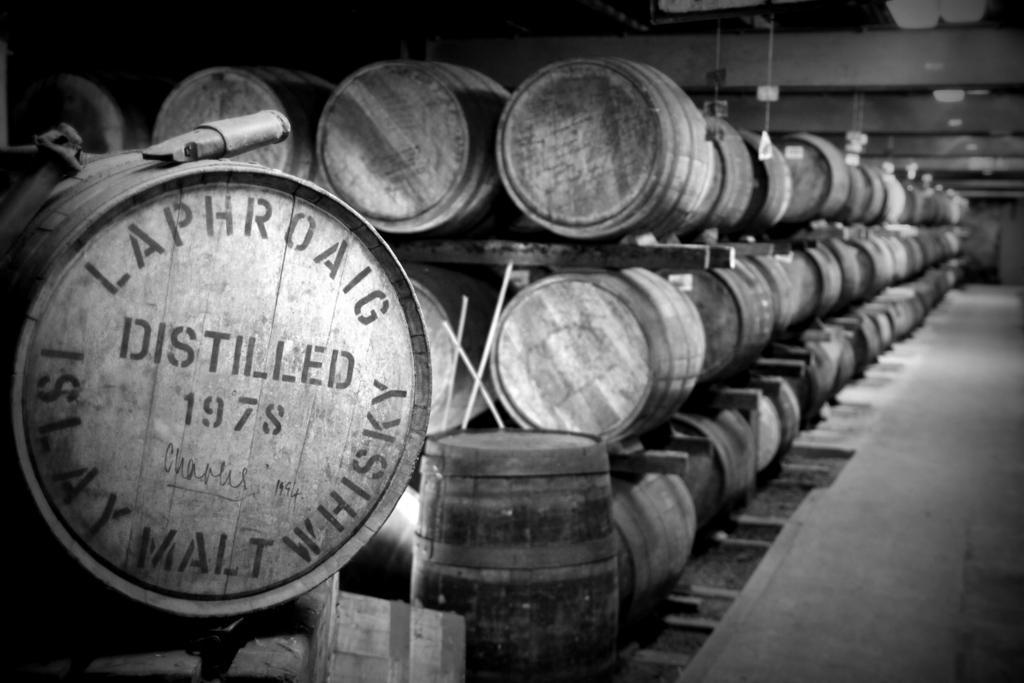In one or two sentences, can you explain what this image depicts? This is a black and white image. In this image we can see barrels on racks. On the barrel something is written. 